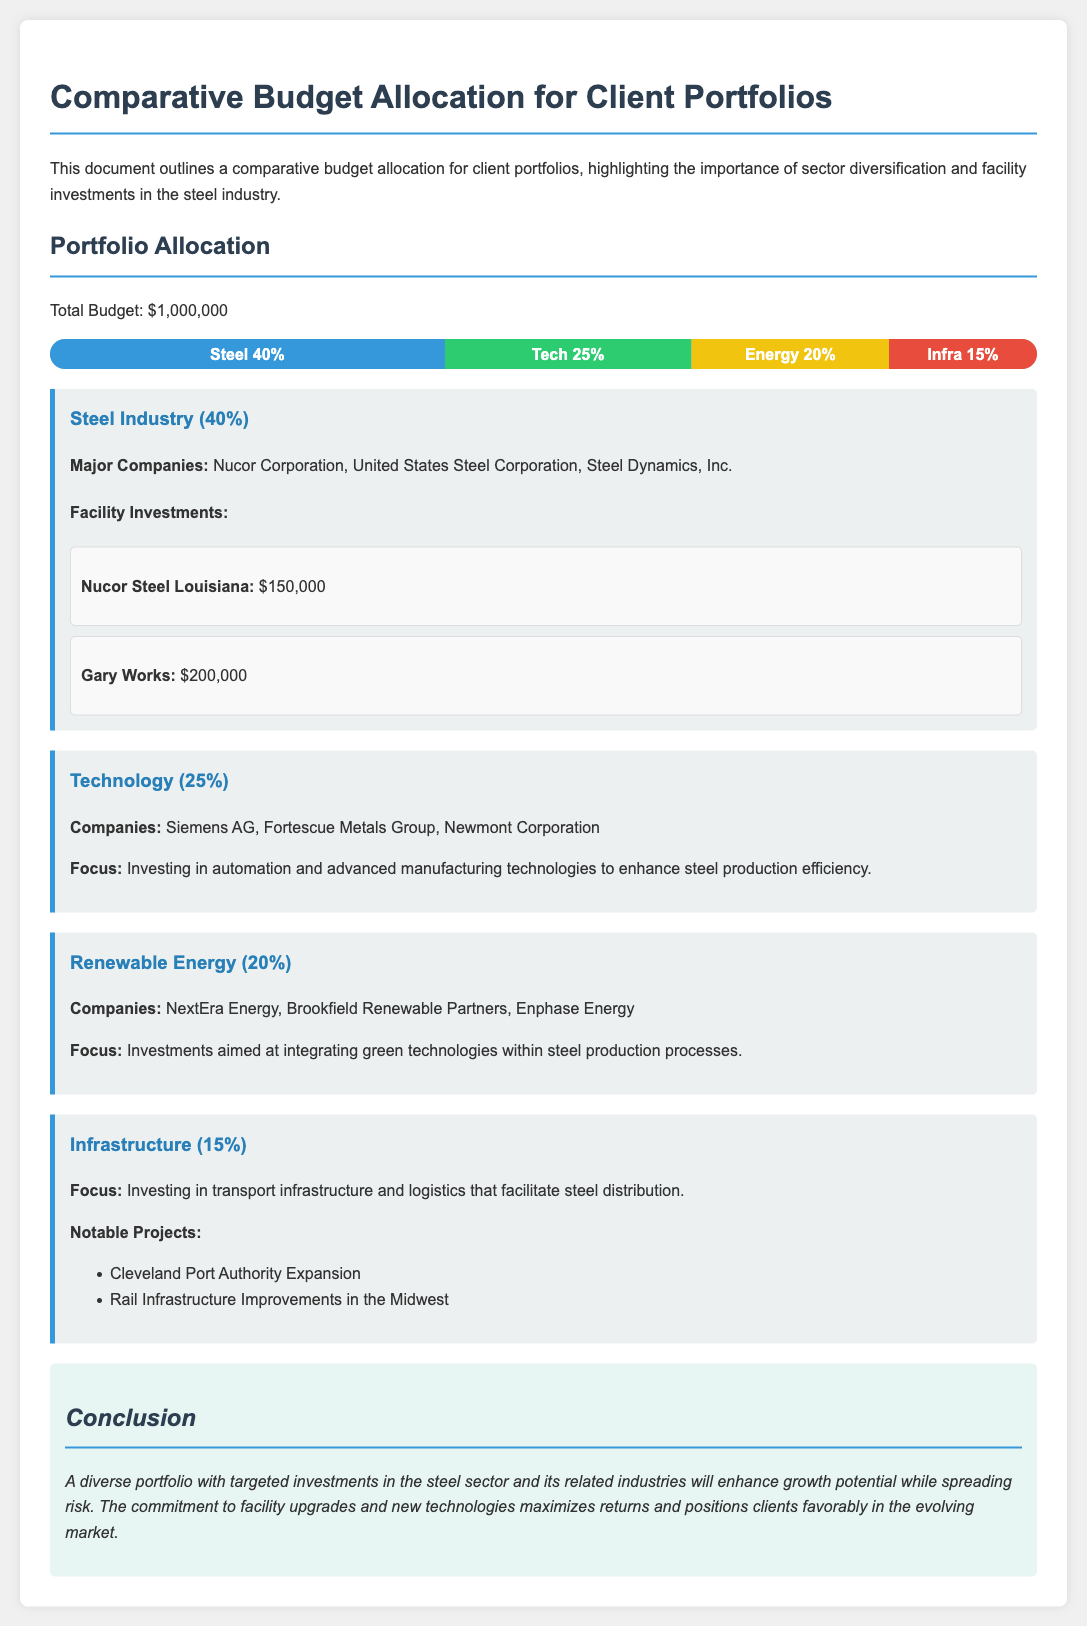What is the total budget? The total budget is stated at the beginning of the document.
Answer: $1,000,000 What percentage of the budget is allocated to the steel industry? The percentage allocated to the steel industry is provided in the section header.
Answer: 40% Which company has a facility investment of $200,000? The document lists Nucor Steel Louisiana and Gary Works, one of which has a $200,000 investment.
Answer: Gary Works What is the focus of the Technology sector investments? The document describes the focus of the Technology sector regarding the steel industry.
Answer: Investing in automation How many notable projects are listed under the Infrastructure sector? The number of notable projects is indicated by the list provided in that section.
Answer: 2 What is the major investment facility mentioned for Nucor Corporation? The document specifies the investment name and its amount for Nucor Corporation.
Answer: Nucor Steel Louisiana What is the focus of renewable energy investments within steel production? The document outlines the focus area for renewable energy investments.
Answer: Integrating green technologies Which sector has a higher budget percentage, Technology or Energy? The comparison of the percentage allocation indicates which sector has more budget.
Answer: Technology 